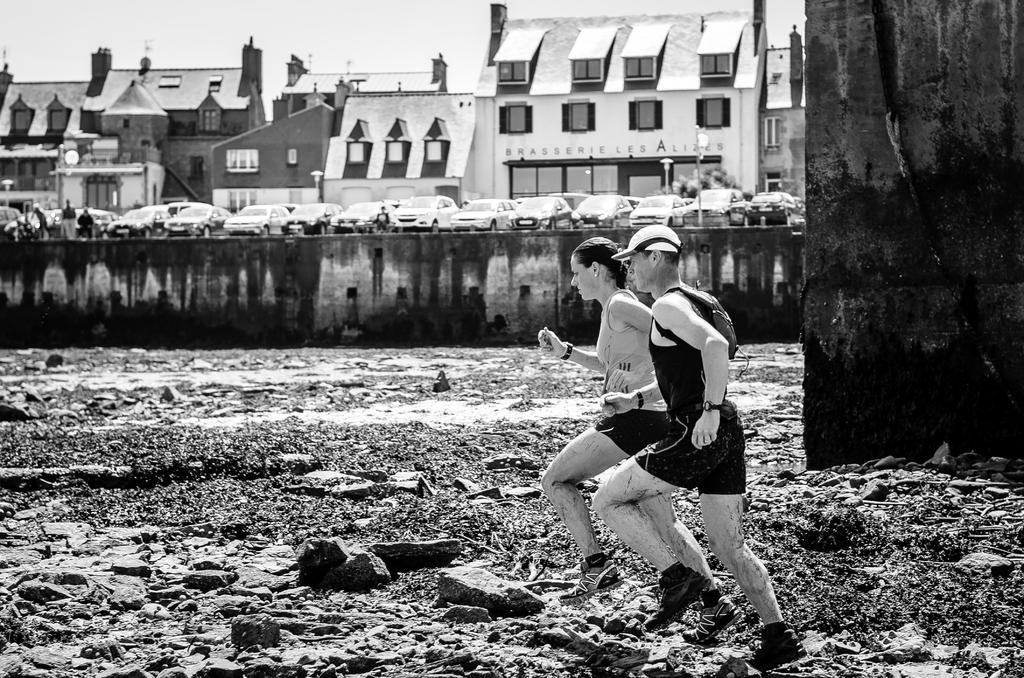What are the two people in the image doing? The two people in the image are running. On what surface are the people running? The people are running on the ground. What can be seen in the background of the image? There are buildings and the sky visible in the background of the image. What is parked in front of the buildings? Cars are parked in front of the buildings. What type of scale can be seen in the image? There is no scale present in the image. Can you tell me how the people are saying good-bye to each other in the image? The image does not show the people saying good-bye to each other; they are running. 